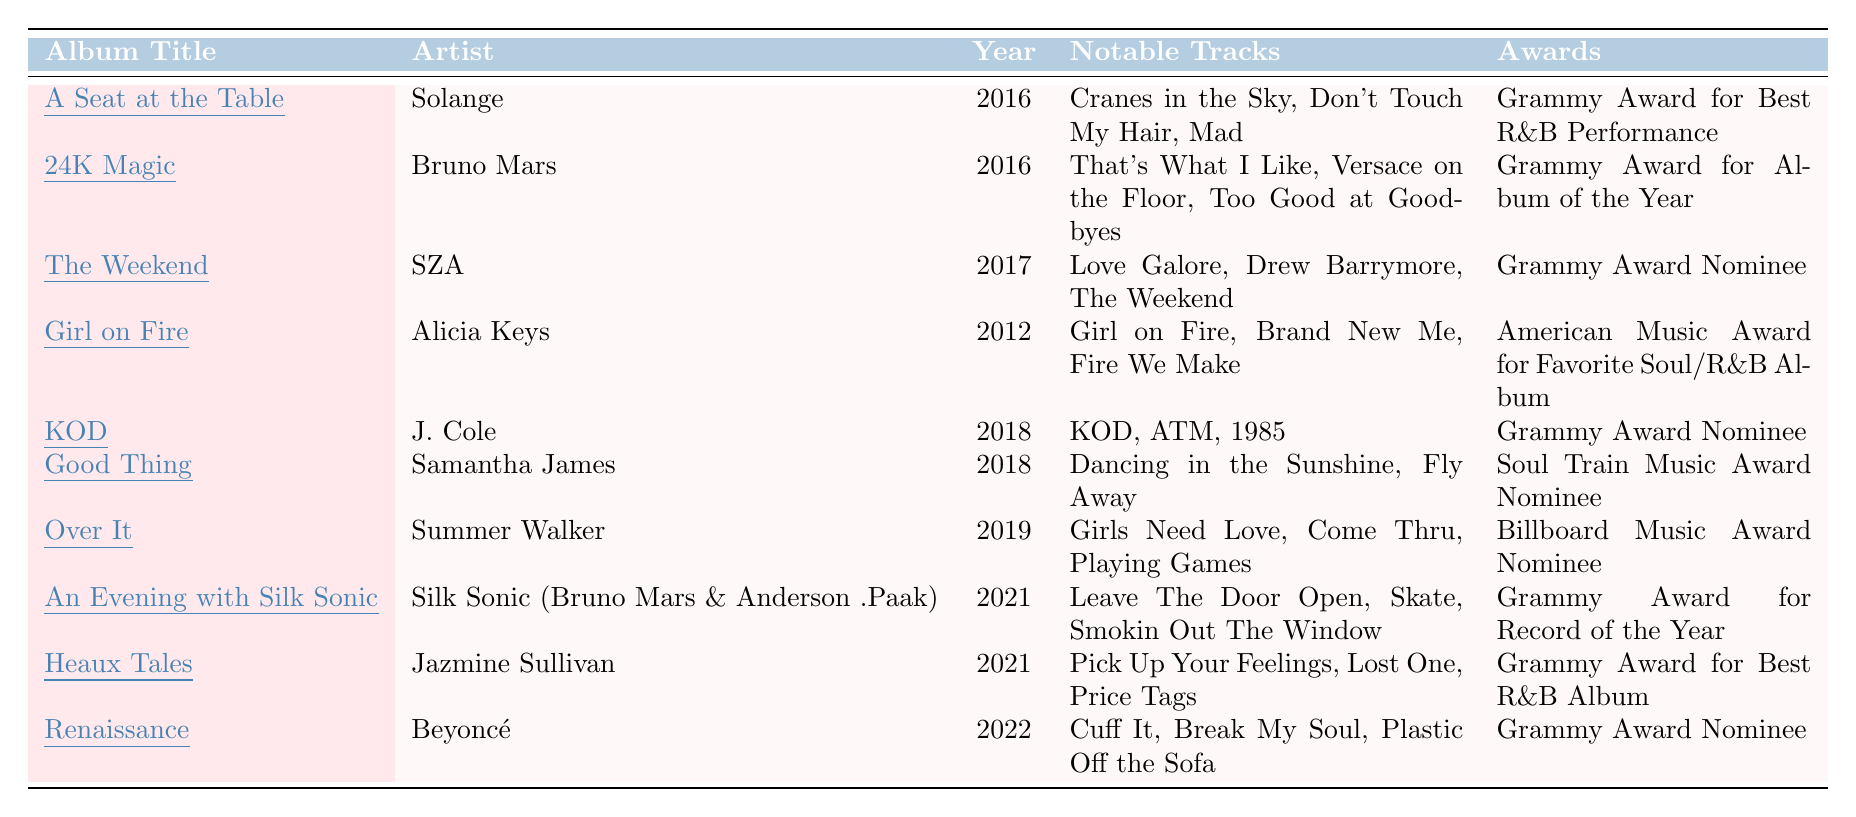What is the release year of "A Seat at the Table"? The release year for "A Seat at the Table" is listed in the 'Year' column next to the album title. It shows 2016.
Answer: 2016 Which artist released the album "24K Magic"? The album "24K Magic" is listed in the 'Album Title' column, and its corresponding 'Artist' is shown as Bruno Mars in the same row.
Answer: Bruno Mars How many Grammy Awards has "Heaux Tales" won? The 'Awards' column next to "Heaux Tales" lists "Grammy Award for Best R&B Album", indicating that it has won one Grammy Award.
Answer: One Which album features the notable track "Leave The Door Open"? By examining the 'Notable Tracks' for each album, "Leave The Door Open" is listed under "An Evening with Silk Sonic".
Answer: An Evening with Silk Sonic Is "Girl on Fire" an R&B album released in the last decade? "Girl on Fire" was released in 2012, which is outside the last decade (2013-2023), so the statement is false.
Answer: No How many albums listed in the table are Grammy Award nominees but did not win an award? The albums "The Weekend", "KOD", "Over It", and "Renaissance" are nominated for Grammys but did not win any, totaling four albums.
Answer: Four Which artist has the most albums listed, and how many are there? Counting the entries, Bruno Mars has two albums listed: "24K Magic" and "An Evening with Silk Sonic".
Answer: Bruno Mars, 2 What is the average release year of the albums in the table? The release years are 2016, 2016, 2017, 2012, 2018, 2018, 2019, 2021, 2021, and 2022. The sum is 2016 + 2016 + 2017 + 2012 + 2018 + 2018 + 2019 + 2021 + 2021 + 2022 = 20178, and there are 10 albums, so the average release year is 20178 / 10 = 2017.8, which rounds to 2018.
Answer: 2018 Which of the listed albums has won the most prestigious Grammy Award? "24K Magic" won the Grammy Award for Album of the Year, which is considered one of the most prestigious awards, more so than other awards listed.
Answer: 24K Magic List the notable tracks of "Over It". The notable tracks are presented in the 'Notable Tracks' column; they are "Girls Need Love", "Come Thru", and "Playing Games".
Answer: Girls Need Love, Come Thru, Playing Games 